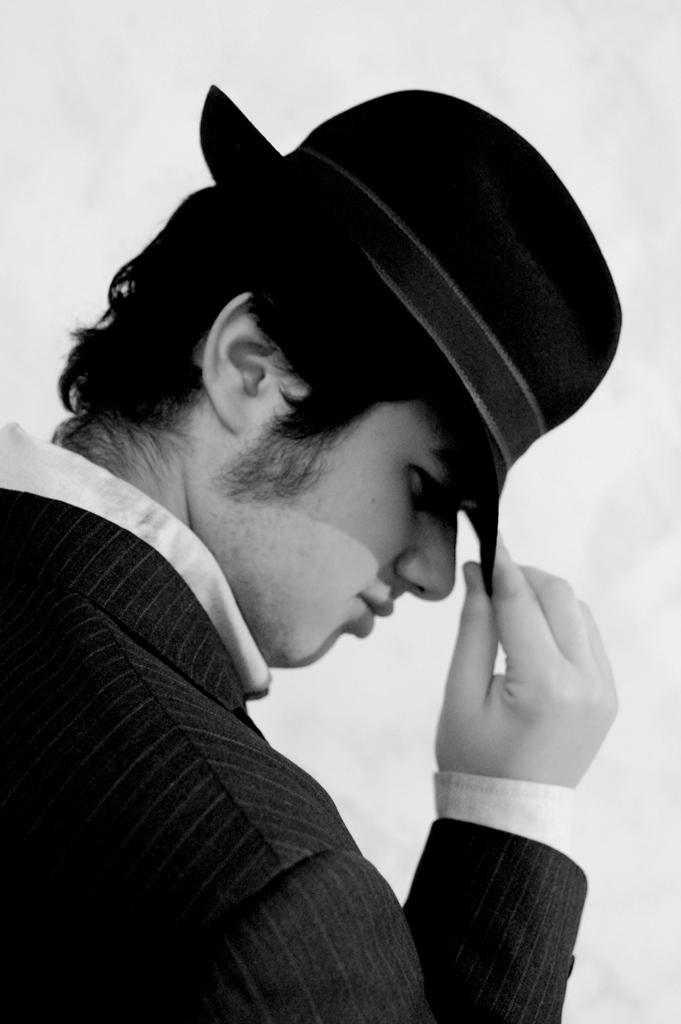What is the color scheme of the image? The image is black and white. What can be seen in the center of the image? There is a person standing in the center of the image. What is the person wearing on their head? The person is wearing a hat. What color is the background of the image? The background of the image is white. Reasoning: Let' Let's think step by step in order to produce the conversation. We start by identifying the color scheme of the image, which is black and white. Then, we focus on the main subject in the image, which is the person standing in the center. We describe the person's attire, specifically mentioning the hat they are wearing. Finally, we describe the background of the image, which is white. Absurd Question/Answer: What type of leather can be seen in the image? There is no leather present in the image. What kind of flowers are growing in the background of the image? There are no flowers visible in the image, as the background is white. 